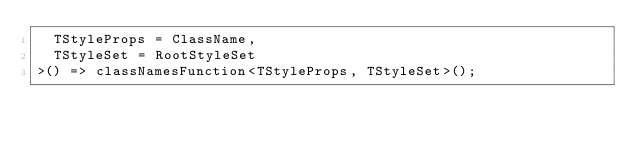Convert code to text. <code><loc_0><loc_0><loc_500><loc_500><_TypeScript_>  TStyleProps = ClassName,
  TStyleSet = RootStyleSet
>() => classNamesFunction<TStyleProps, TStyleSet>();
</code> 